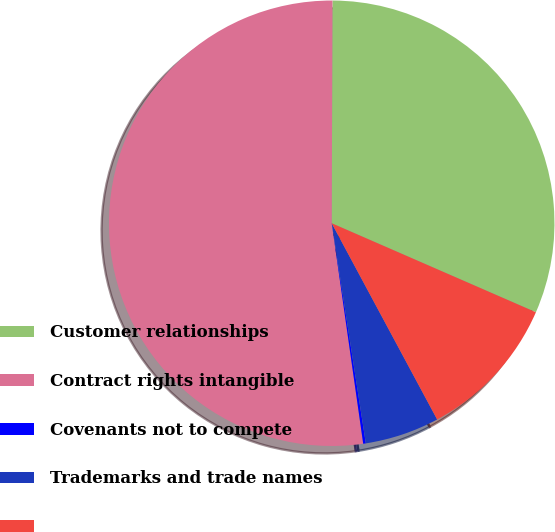Convert chart to OTSL. <chart><loc_0><loc_0><loc_500><loc_500><pie_chart><fcel>Customer relationships<fcel>Contract rights intangible<fcel>Covenants not to compete<fcel>Trademarks and trade names<fcel>Unnamed: 4<nl><fcel>31.49%<fcel>52.31%<fcel>0.19%<fcel>5.4%<fcel>10.61%<nl></chart> 